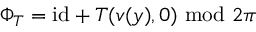Convert formula to latex. <formula><loc_0><loc_0><loc_500><loc_500>\Phi _ { T } = i d + T ( v ( y ) , 0 ) \ m o d \ 2 \pi</formula> 